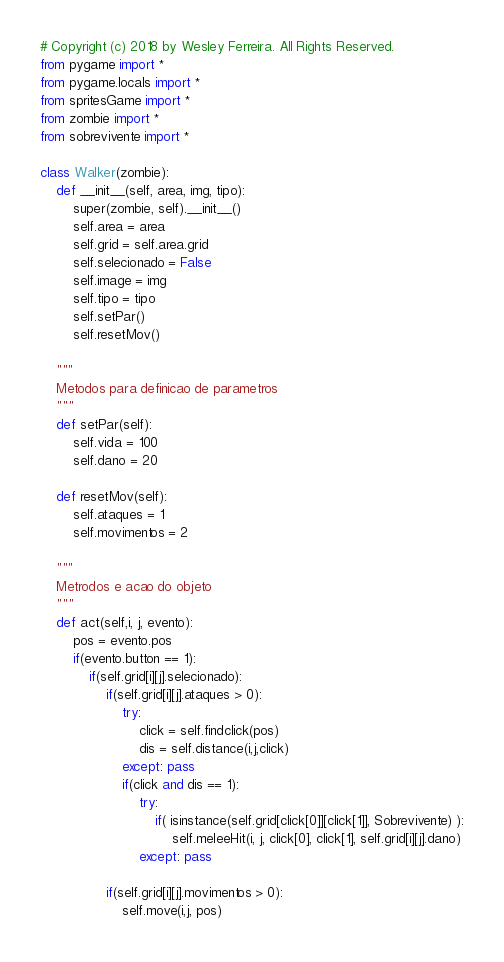Convert code to text. <code><loc_0><loc_0><loc_500><loc_500><_Python_># Copyright (c) 2018 by Wesley Ferreira. All Rights Reserved.
from pygame import *
from pygame.locals import *
from spritesGame import *
from zombie import *
from sobrevivente import *

class Walker(zombie):
    def __init__(self, area, img, tipo):
        super(zombie, self).__init__()
        self.area = area
        self.grid = self.area.grid
        self.selecionado = False
        self.image = img
        self.tipo = tipo
        self.setPar()
        self.resetMov()

    """
    Metodos para definicao de parametros
    """
    def setPar(self):
        self.vida = 100
        self.dano = 20

    def resetMov(self):
        self.ataques = 1
        self.movimentos = 2

    """
    Metrodos e acao do objeto
    """
    def act(self,i, j, evento):
        pos = evento.pos
        if(evento.button == 1):
            if(self.grid[i][j].selecionado):
                if(self.grid[i][j].ataques > 0):
                    try:
                        click = self.findclick(pos)
                        dis = self.distance(i,j,click)
                    except: pass
                    if(click and dis == 1):
                        try:
                            if( isinstance(self.grid[click[0]][click[1]], Sobrevivente) ):
                                self.meleeHit(i, j, click[0], click[1], self.grid[i][j].dano)
                        except: pass

                if(self.grid[i][j].movimentos > 0):
                    self.move(i,j, pos)
</code> 